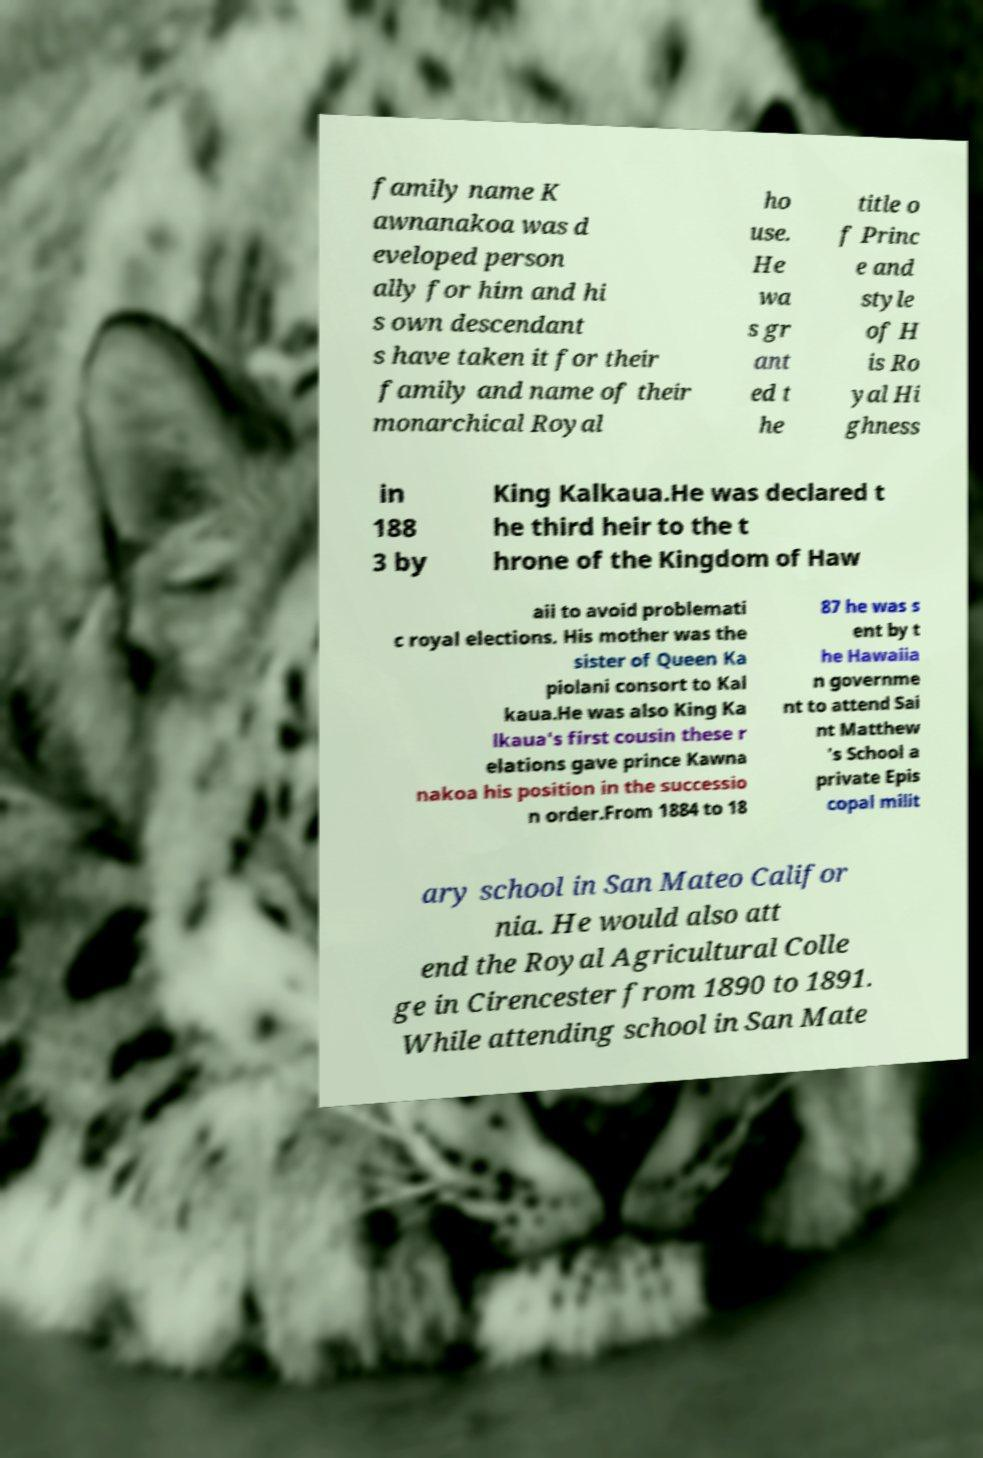Could you assist in decoding the text presented in this image and type it out clearly? family name K awnanakoa was d eveloped person ally for him and hi s own descendant s have taken it for their family and name of their monarchical Royal ho use. He wa s gr ant ed t he title o f Princ e and style of H is Ro yal Hi ghness in 188 3 by King Kalkaua.He was declared t he third heir to the t hrone of the Kingdom of Haw aii to avoid problemati c royal elections. His mother was the sister of Queen Ka piolani consort to Kal kaua.He was also King Ka lkaua's first cousin these r elations gave prince Kawna nakoa his position in the successio n order.From 1884 to 18 87 he was s ent by t he Hawaiia n governme nt to attend Sai nt Matthew 's School a private Epis copal milit ary school in San Mateo Califor nia. He would also att end the Royal Agricultural Colle ge in Cirencester from 1890 to 1891. While attending school in San Mate 